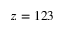<formula> <loc_0><loc_0><loc_500><loc_500>z = 1 2 3</formula> 